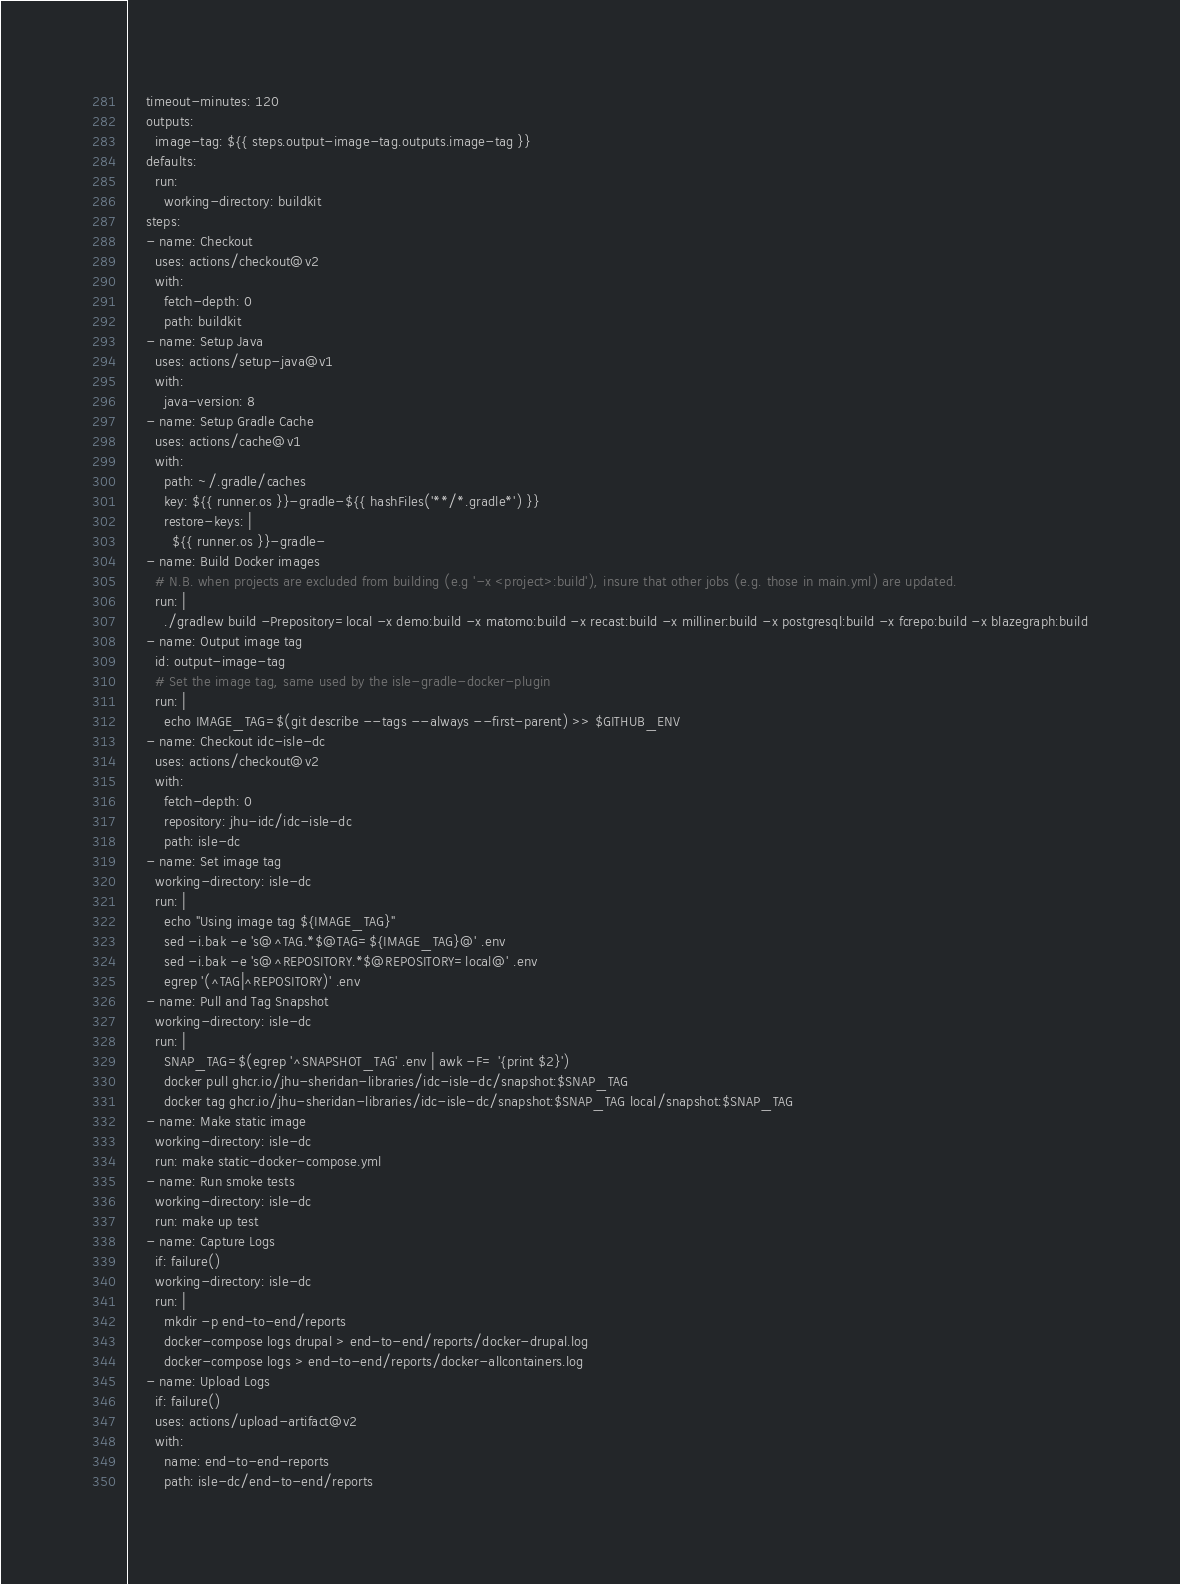Convert code to text. <code><loc_0><loc_0><loc_500><loc_500><_YAML_>    timeout-minutes: 120
    outputs:
      image-tag: ${{ steps.output-image-tag.outputs.image-tag }}
    defaults:
      run:
        working-directory: buildkit
    steps:
    - name: Checkout
      uses: actions/checkout@v2
      with:
        fetch-depth: 0
        path: buildkit
    - name: Setup Java
      uses: actions/setup-java@v1
      with:
        java-version: 8
    - name: Setup Gradle Cache
      uses: actions/cache@v1
      with:
        path: ~/.gradle/caches
        key: ${{ runner.os }}-gradle-${{ hashFiles('**/*.gradle*') }}
        restore-keys: |
          ${{ runner.os }}-gradle-
    - name: Build Docker images
      # N.B. when projects are excluded from building (e.g '-x <project>:build'), insure that other jobs (e.g. those in main.yml) are updated.
      run: |
        ./gradlew build -Prepository=local -x demo:build -x matomo:build -x recast:build -x milliner:build -x postgresql:build -x fcrepo:build -x blazegraph:build
    - name: Output image tag
      id: output-image-tag
      # Set the image tag, same used by the isle-gradle-docker-plugin
      run: |
        echo IMAGE_TAG=$(git describe --tags --always --first-parent) >> $GITHUB_ENV
    - name: Checkout idc-isle-dc
      uses: actions/checkout@v2
      with:
        fetch-depth: 0
        repository: jhu-idc/idc-isle-dc
        path: isle-dc
    - name: Set image tag
      working-directory: isle-dc
      run: |
        echo "Using image tag ${IMAGE_TAG}"
        sed -i.bak -e 's@^TAG.*$@TAG=${IMAGE_TAG}@' .env
        sed -i.bak -e 's@^REPOSITORY.*$@REPOSITORY=local@' .env
        egrep '(^TAG|^REPOSITORY)' .env
    - name: Pull and Tag Snapshot
      working-directory: isle-dc
      run: |
        SNAP_TAG=$(egrep '^SNAPSHOT_TAG' .env | awk -F= '{print $2}')
        docker pull ghcr.io/jhu-sheridan-libraries/idc-isle-dc/snapshot:$SNAP_TAG
        docker tag ghcr.io/jhu-sheridan-libraries/idc-isle-dc/snapshot:$SNAP_TAG local/snapshot:$SNAP_TAG
    - name: Make static image
      working-directory: isle-dc
      run: make static-docker-compose.yml
    - name: Run smoke tests
      working-directory: isle-dc
      run: make up test
    - name: Capture Logs
      if: failure()
      working-directory: isle-dc
      run: |
        mkdir -p end-to-end/reports
        docker-compose logs drupal > end-to-end/reports/docker-drupal.log
        docker-compose logs > end-to-end/reports/docker-allcontainers.log
    - name: Upload Logs
      if: failure()
      uses: actions/upload-artifact@v2
      with:
        name: end-to-end-reports
        path: isle-dc/end-to-end/reports
</code> 